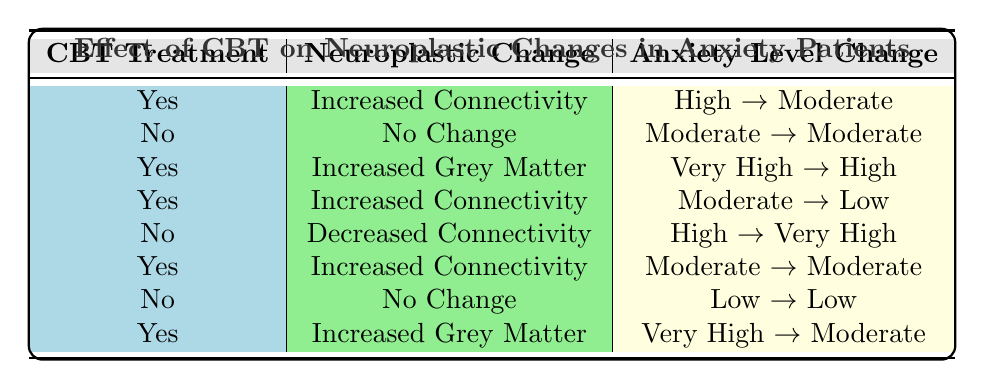What percentage of patients underwent CBT treatment? There are 8 patients in total. Out of these, 5 patients received CBT, which is calculated as (5/8) * 100 = 62.5%.
Answer: 62.5% How many patients experienced "Increased Connectivity" as a neuroplastic change? By examining the table, we find that there are 3 patients (Patient 1, 4, and 6) who reported "Increased Connectivity".
Answer: 3 Did any patients have a "No Change" neuroplastic change after receiving CBT treatment? By checking the table, there are no patients who underwent CBT treatment and also reported "No Change".
Answer: No What is the change in anxiety level for the patient who showed "Increased Grey Matter"? There are 2 patients who exhibited "Increased Grey Matter" (Patients 3 and 8). Patient 3 had a change from "Very High" to "High", and Patient 8 changed from "Very High" to "Moderate". Thus, the anxiety level changed for both but specifically for Patient 3 it's from "Very High" to "High".
Answer: Very High to High How many patients experienced a decrease in their anxiety level after treatment? To identify the decrease, we check the "Anxiety Level Before" and "Anxiety Level After" columns for each patient. Patients 1, 4, and 8 saw a decrease in anxiety levels. Thus, there are 3 patients with decreased anxiety levels after treatment.
Answer: 3 What are the anxiety level changes for patients who did not receive CBT treatment? For patients without CBT (Patients 2, 5, and 7): Patient 2's anxiety level remained "Moderate", Patient 5's anxiety level increased from "High" to "Very High", and Patient 7's anxiety level remained "Low". Therefore, one patient had no change while two had varying results.
Answer: Moderate, Very High, Low How many patients showed a moderate anxiety level change after CBT treatment? We observe the post-treatment anxiety levels of patients who underwent CBT. Patient 1 changed from "High" to "Moderate", Patient 6 remained "Moderate", and Patient 8 decreased to "Moderate". Therefore, there are 3 patients showing moderate anxiety levels changes post-CBT.
Answer: 3 Is there any correlation between "Increased Connectivity" and reduced anxiety levels after CBT? By reviewing the rows, Patients 1 and 4 both had "Increased Connectivity" and showed reduced anxiety levels after CBT treatment (from High to Moderate and Moderate to Low, respectively). Thus, there is an indication of correlation between "Increased Connectivity" and reduced anxiety levels.
Answer: Yes 